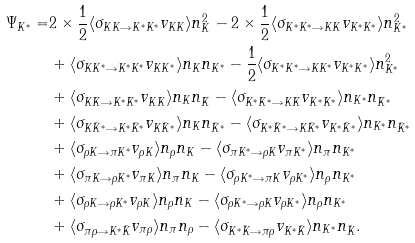Convert formula to latex. <formula><loc_0><loc_0><loc_500><loc_500>\Psi _ { K ^ { \ast } } = & 2 \times \frac { 1 } { 2 } \langle \sigma _ { K K \rightarrow K ^ { \ast } K ^ { \ast } } v _ { K K } \rangle n _ { K } ^ { 2 } - 2 \times \frac { 1 } { 2 } \langle \sigma _ { K ^ { \ast } K ^ { \ast } \rightarrow K K } v _ { K ^ { \ast } K ^ { \ast } } \rangle n _ { K ^ { \ast } } ^ { 2 } \\ & + \langle \sigma _ { K K ^ { \ast } \rightarrow K ^ { \ast } K ^ { \ast } } v _ { K K ^ { \ast } } \rangle n _ { K } n _ { K ^ { \ast } } - \frac { 1 } { 2 } \langle \sigma _ { K ^ { \ast } K ^ { \ast } \rightarrow K K ^ { \ast } } v _ { K ^ { \ast } K ^ { \ast } } \rangle n _ { K ^ { \ast } } ^ { 2 } \\ & + \langle \sigma _ { K \bar { K } \rightarrow K ^ { \ast } \bar { K } ^ { \ast } } v _ { K \bar { K } } \rangle n _ { K } n _ { \bar { K } } - \langle \sigma _ { K ^ { \ast } \bar { K } ^ { \ast } \rightarrow K \bar { K } } v _ { K ^ { \ast } \bar { K } ^ { \ast } } \rangle n _ { K ^ { \ast } } n _ { \bar { K } ^ { \ast } } \\ & + \langle \sigma _ { K \bar { K } ^ { \ast } \rightarrow K ^ { \ast } \bar { K } ^ { \ast } } v _ { K \bar { K } ^ { \ast } } \rangle n _ { K } n _ { \bar { K } ^ { \ast } } - \langle \sigma _ { K ^ { \ast } \bar { K } ^ { \ast } \rightarrow K \bar { K } ^ { \ast } } v _ { K ^ { \ast } \bar { K } ^ { \ast } } \rangle n _ { K ^ { \ast } } n _ { \bar { K } ^ { \ast } } \\ & + \langle \sigma _ { \rho K \rightarrow \pi K ^ { \ast } } v _ { \rho K } \rangle n _ { \rho } n _ { K } - \langle \sigma _ { \pi K ^ { \ast } \rightarrow \rho K } v _ { \pi K ^ { \ast } } \rangle n _ { \pi } n _ { K ^ { \ast } } \\ & + \langle \sigma _ { \pi K \rightarrow \rho K ^ { \ast } } v _ { \pi K } \rangle n _ { \pi } n _ { K } - \langle \sigma _ { \rho K ^ { \ast } \rightarrow \pi K } v _ { \rho K ^ { \ast } } \rangle n _ { \rho } n _ { K ^ { \ast } } \\ & + \langle \sigma _ { \rho K \rightarrow \rho K ^ { \ast } } v _ { \rho K } \rangle n _ { \rho } n _ { K } - \langle \sigma _ { \rho K ^ { \ast } \rightarrow \rho K } v _ { \rho K ^ { \ast } } \rangle n _ { \rho } n _ { K ^ { \ast } } \\ & + \langle \sigma _ { \pi \rho \rightarrow K ^ { \ast } \bar { K } } v _ { \pi \rho } \rangle n _ { \pi } n _ { \rho } - \langle \sigma _ { K ^ { \ast } \bar { K } \rightarrow \pi \rho } v _ { K ^ { \ast } \bar { K } } \rangle n _ { K ^ { \ast } } n _ { \bar { K } } .</formula> 